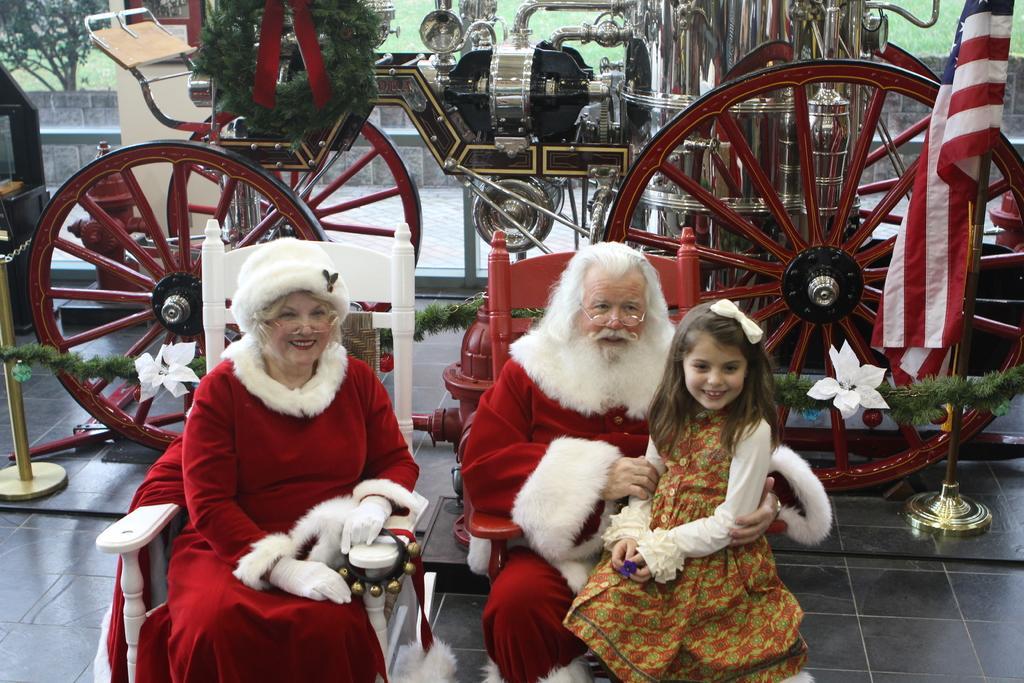Please provide a concise description of this image. In the image there is a woman and man in santa claus costume sitting on chairs and a girl sitting on man, behind them there is a chariot on the floor. 